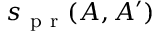<formula> <loc_0><loc_0><loc_500><loc_500>s _ { p r } ( A , A ^ { \prime } )</formula> 